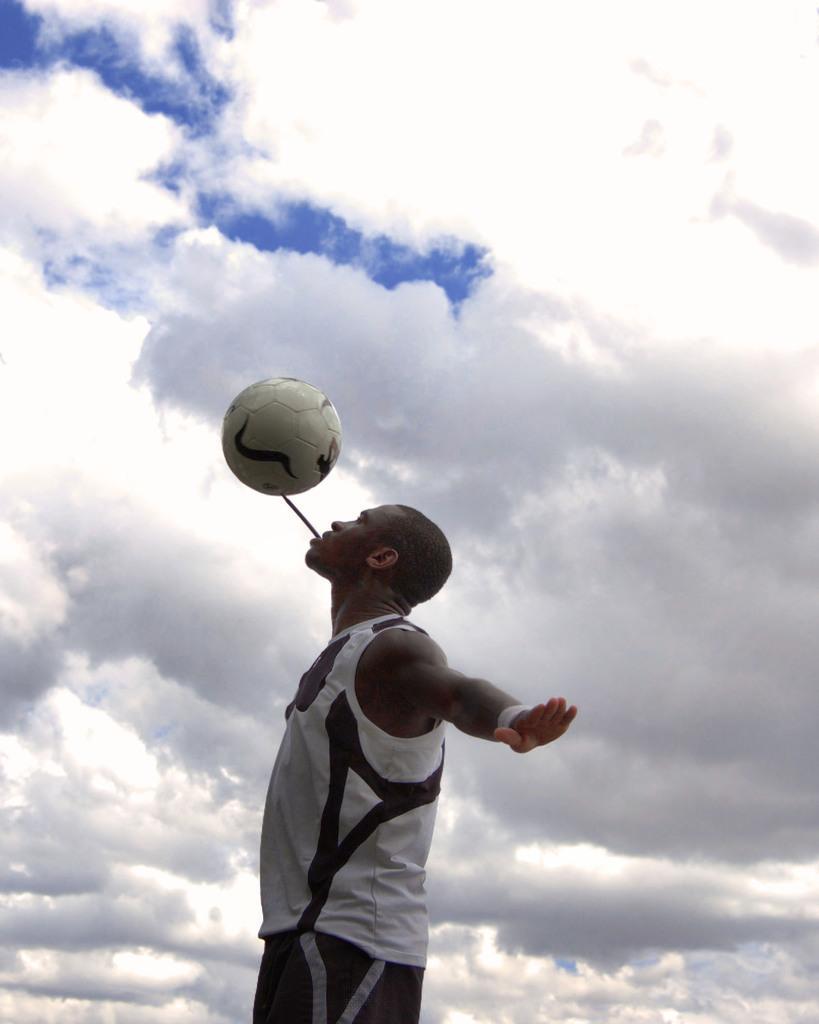Please provide a concise description of this image. On the background we can see blue sky with clouds. Here we can see one man wearing a white cloud shirt. he wore wrist band and he is holding a ball with a stick in his mouth. 